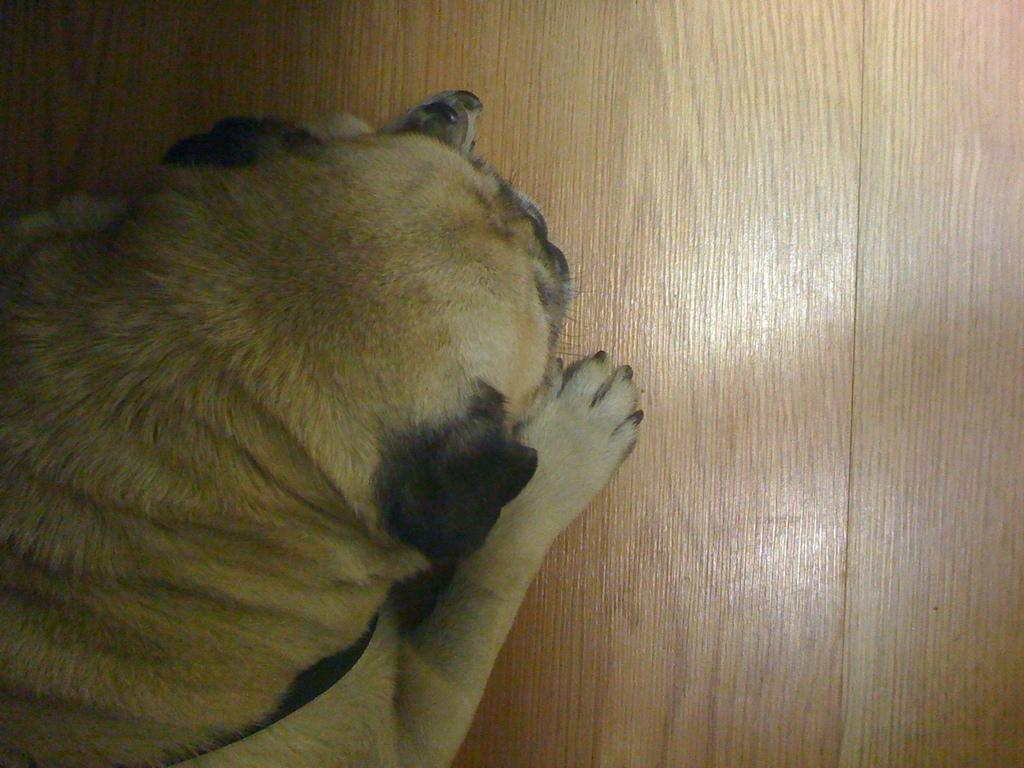What type of animal is in the image? There is a dog in the image. What surface is the dog on? The dog is on a wooden surface. Where is the yam located in the image? There is no yam present in the image. What type of throne does the dog sit on in the image? There is no throne present in the image; the dog is on a wooden surface. 